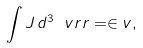Convert formula to latex. <formula><loc_0><loc_0><loc_500><loc_500>\int J \, d ^ { 3 } \ v r r = \in v ,</formula> 